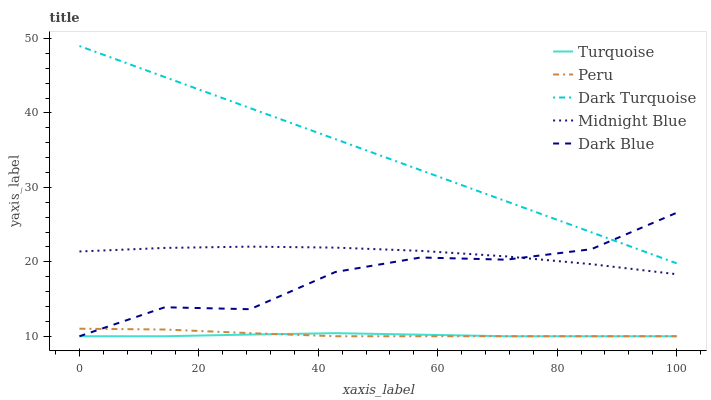Does Turquoise have the minimum area under the curve?
Answer yes or no. Yes. Does Dark Turquoise have the maximum area under the curve?
Answer yes or no. Yes. Does Midnight Blue have the minimum area under the curve?
Answer yes or no. No. Does Midnight Blue have the maximum area under the curve?
Answer yes or no. No. Is Dark Turquoise the smoothest?
Answer yes or no. Yes. Is Dark Blue the roughest?
Answer yes or no. Yes. Is Turquoise the smoothest?
Answer yes or no. No. Is Turquoise the roughest?
Answer yes or no. No. Does Turquoise have the lowest value?
Answer yes or no. Yes. Does Midnight Blue have the lowest value?
Answer yes or no. No. Does Dark Turquoise have the highest value?
Answer yes or no. Yes. Does Midnight Blue have the highest value?
Answer yes or no. No. Is Turquoise less than Dark Turquoise?
Answer yes or no. Yes. Is Dark Turquoise greater than Peru?
Answer yes or no. Yes. Does Dark Blue intersect Dark Turquoise?
Answer yes or no. Yes. Is Dark Blue less than Dark Turquoise?
Answer yes or no. No. Is Dark Blue greater than Dark Turquoise?
Answer yes or no. No. Does Turquoise intersect Dark Turquoise?
Answer yes or no. No. 